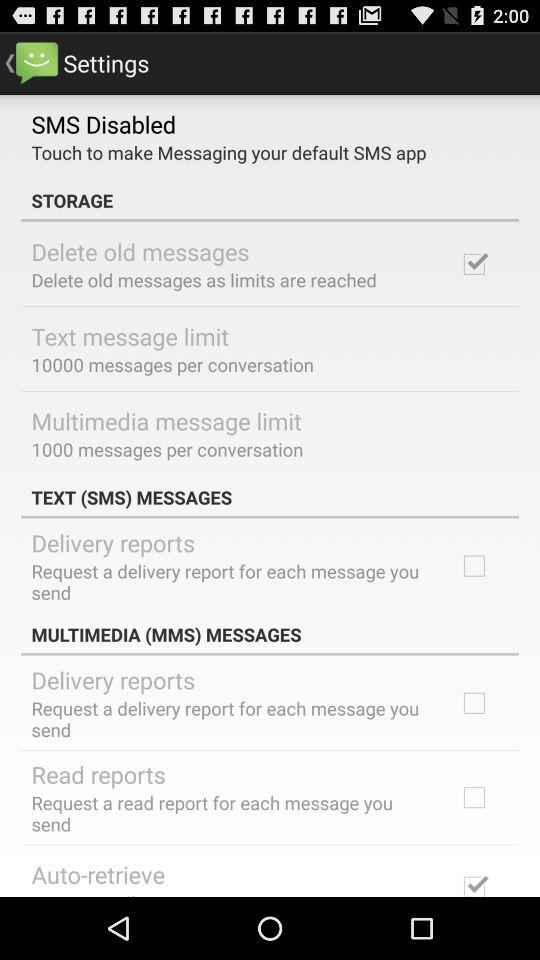What is the maximum limit of text messages per conversation? The maximum limit of text messages per conversation is 10,000. 